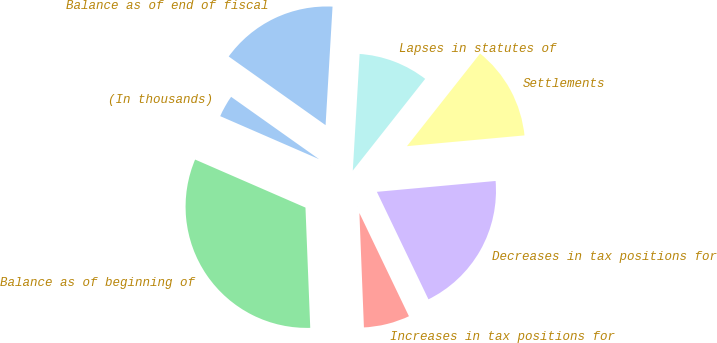Convert chart. <chart><loc_0><loc_0><loc_500><loc_500><pie_chart><fcel>(In thousands)<fcel>Balance as of beginning of<fcel>Increases in tax positions for<fcel>Decreases in tax positions for<fcel>Settlements<fcel>Lapses in statutes of<fcel>Balance as of end of fiscal<nl><fcel>3.28%<fcel>32.16%<fcel>6.49%<fcel>19.33%<fcel>12.91%<fcel>9.7%<fcel>16.12%<nl></chart> 